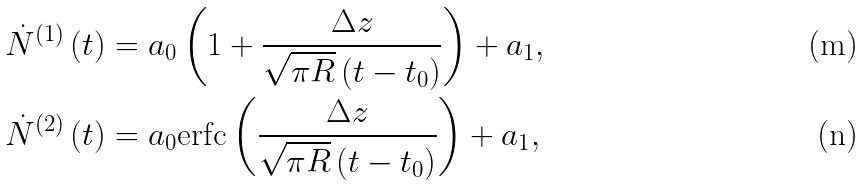Convert formula to latex. <formula><loc_0><loc_0><loc_500><loc_500>\dot { N } ^ { \left ( 1 \right ) } \left ( t \right ) & = a _ { 0 } \left ( 1 + \frac { \Delta z } { \sqrt { \pi R } \left ( t - t _ { 0 } \right ) } \right ) + a _ { 1 } , \\ \dot { N } ^ { \left ( 2 \right ) } \left ( t \right ) & = a _ { 0 } \text {erfc} \left ( \frac { \Delta z } { \sqrt { \pi R } \left ( t - t _ { 0 } \right ) } \right ) + a _ { 1 } ,</formula> 